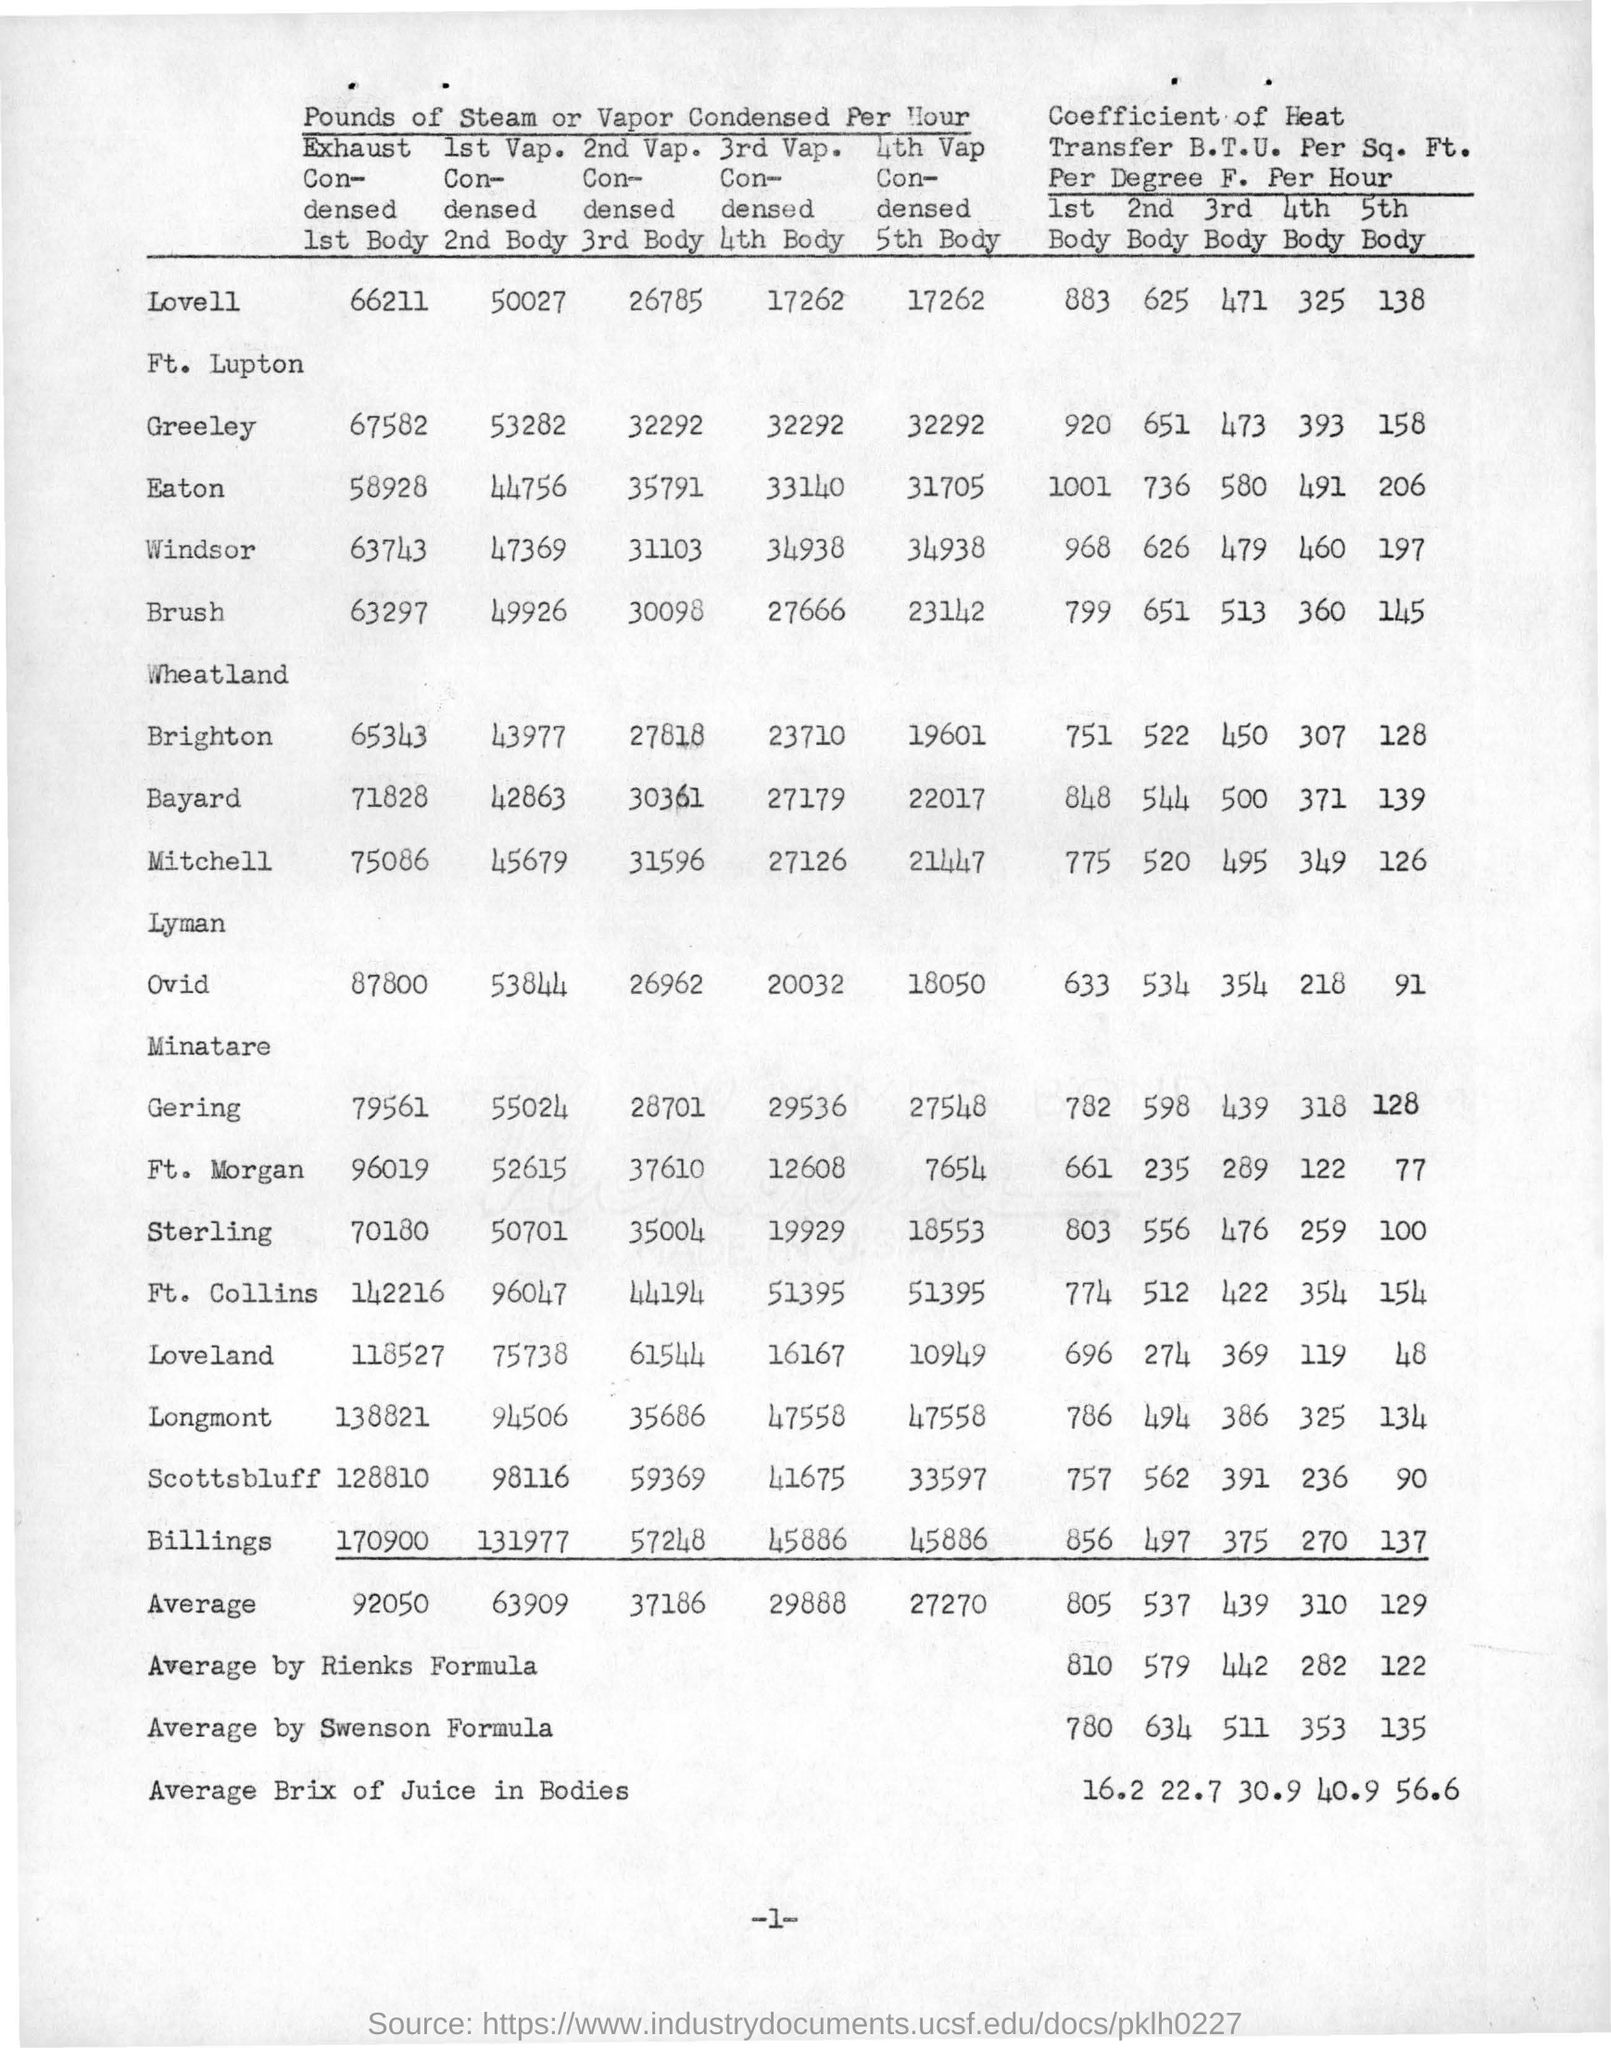What is the value of coefficient of heat for eaton in the 1st body ?
Your response must be concise. 1001. What is the value of vapour condensed per hour for bayard in 2nd body ?
Make the answer very short. 42863. What is the value of average by rienks formula for coefficient of heat in 1st body ?
Your answer should be very brief. 810. What is the value of average by swenson formula for the coefficient of heat in 5th body ?
Your answer should be very brief. 135. What is the value of average brix of juice in bodies for the 3rd body ?
Ensure brevity in your answer.  30.9. 